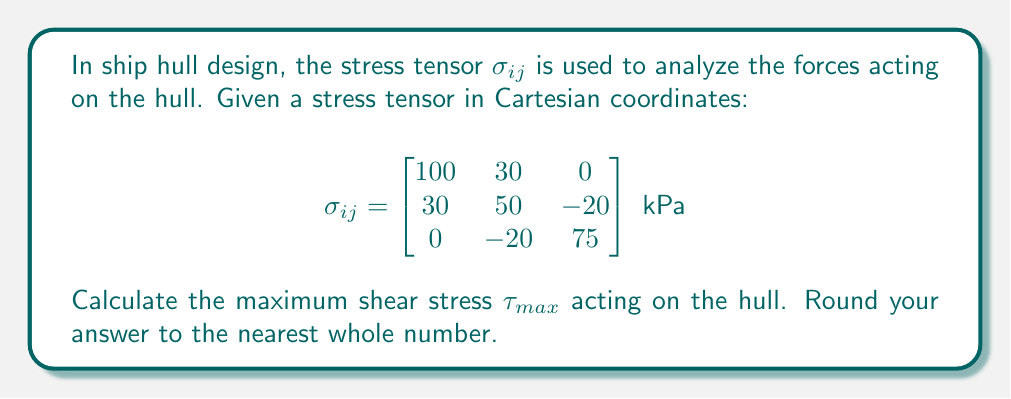Could you help me with this problem? To find the maximum shear stress, we need to follow these steps:

1. Calculate the principal stresses:
   a. Find the characteristic equation:
      $\det(\sigma_{ij} - \lambda I) = 0$
   b. Solve for the eigenvalues (principal stresses)

2. Use the maximum and minimum principal stresses to calculate $\tau_{max}$

Step 1a: Characteristic equation
$$\begin{vmatrix}
100-\lambda & 30 & 0 \\
30 & 50-\lambda & -20 \\
0 & -20 & 75-\lambda
\end{vmatrix} = 0$$

Step 1b: Expanding the determinant:
$$(100-\lambda)(50-\lambda)(75-\lambda) - 30^2(75-\lambda) - 20^2(100-\lambda) = 0$$

$-\lambda^3 + 225\lambda^2 - 14625\lambda + 267500 = 0$

Solving this cubic equation (using a calculator or computer algebra system) yields:

$\lambda_1 \approx 115.8$ kPa
$\lambda_2 \approx 74.7$ kPa
$\lambda_3 \approx 34.5$ kPa

Step 2: Calculate maximum shear stress
The maximum shear stress is given by:

$$\tau_{max} = \frac{\sigma_{max} - \sigma_{min}}{2}$$

Where $\sigma_{max} = \lambda_1$ and $\sigma_{min} = \lambda_3$

$$\tau_{max} = \frac{115.8 - 34.5}{2} \approx 40.65 \text{ kPa}$$

Rounding to the nearest whole number: 41 kPa
Answer: 41 kPa 